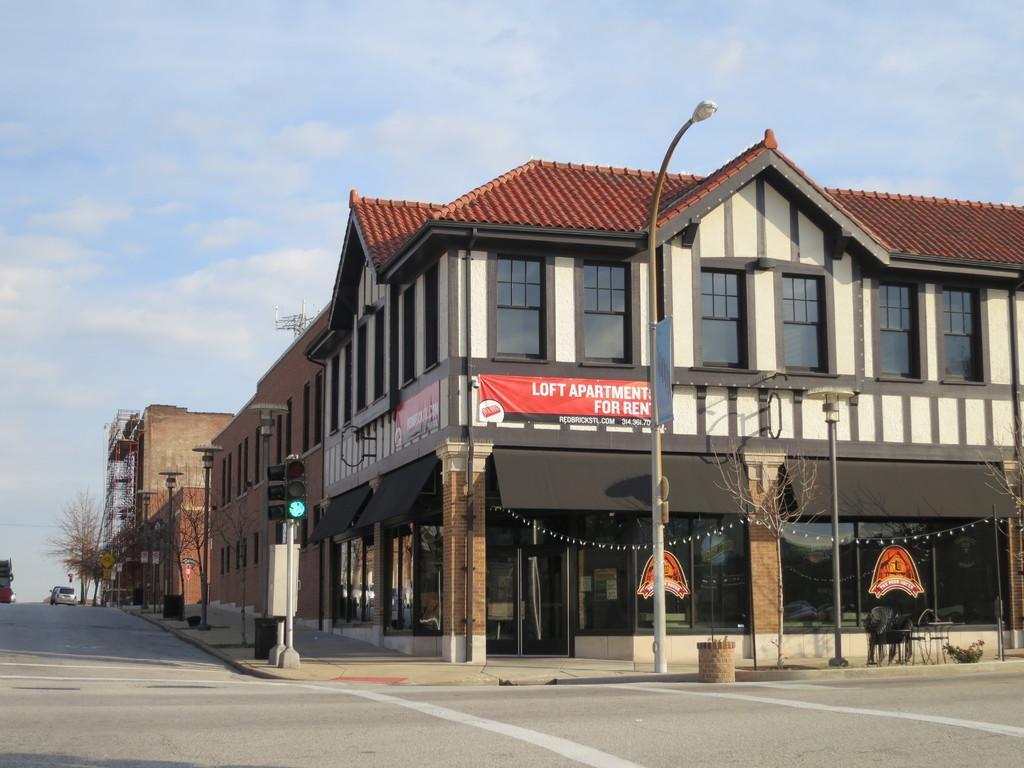Please provide a concise description of this image. On the left side of the image I can see vehicle is on the road. In the front of the image there are light poles, signal lights, trees, buildings, banners, pillars and objects. In the background of the image there is a cloudy sky. 